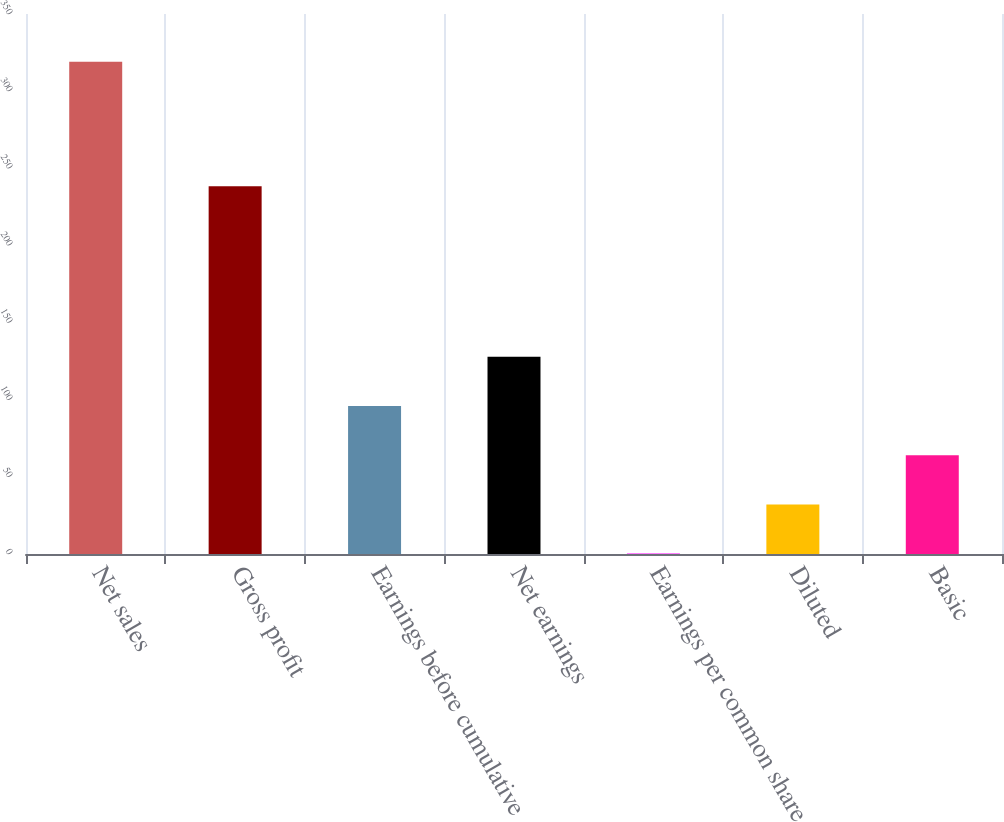Convert chart to OTSL. <chart><loc_0><loc_0><loc_500><loc_500><bar_chart><fcel>Net sales<fcel>Gross profit<fcel>Earnings before cumulative<fcel>Net earnings<fcel>Earnings per common share<fcel>Diluted<fcel>Basic<nl><fcel>319.1<fcel>238.3<fcel>95.92<fcel>127.8<fcel>0.28<fcel>32.16<fcel>64.04<nl></chart> 